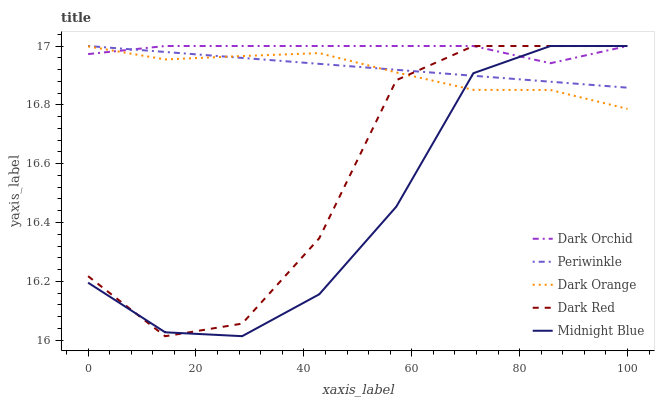Does Midnight Blue have the minimum area under the curve?
Answer yes or no. Yes. Does Dark Orchid have the maximum area under the curve?
Answer yes or no. Yes. Does Periwinkle have the minimum area under the curve?
Answer yes or no. No. Does Periwinkle have the maximum area under the curve?
Answer yes or no. No. Is Periwinkle the smoothest?
Answer yes or no. Yes. Is Dark Red the roughest?
Answer yes or no. Yes. Is Midnight Blue the smoothest?
Answer yes or no. No. Is Midnight Blue the roughest?
Answer yes or no. No. Does Periwinkle have the lowest value?
Answer yes or no. No. 